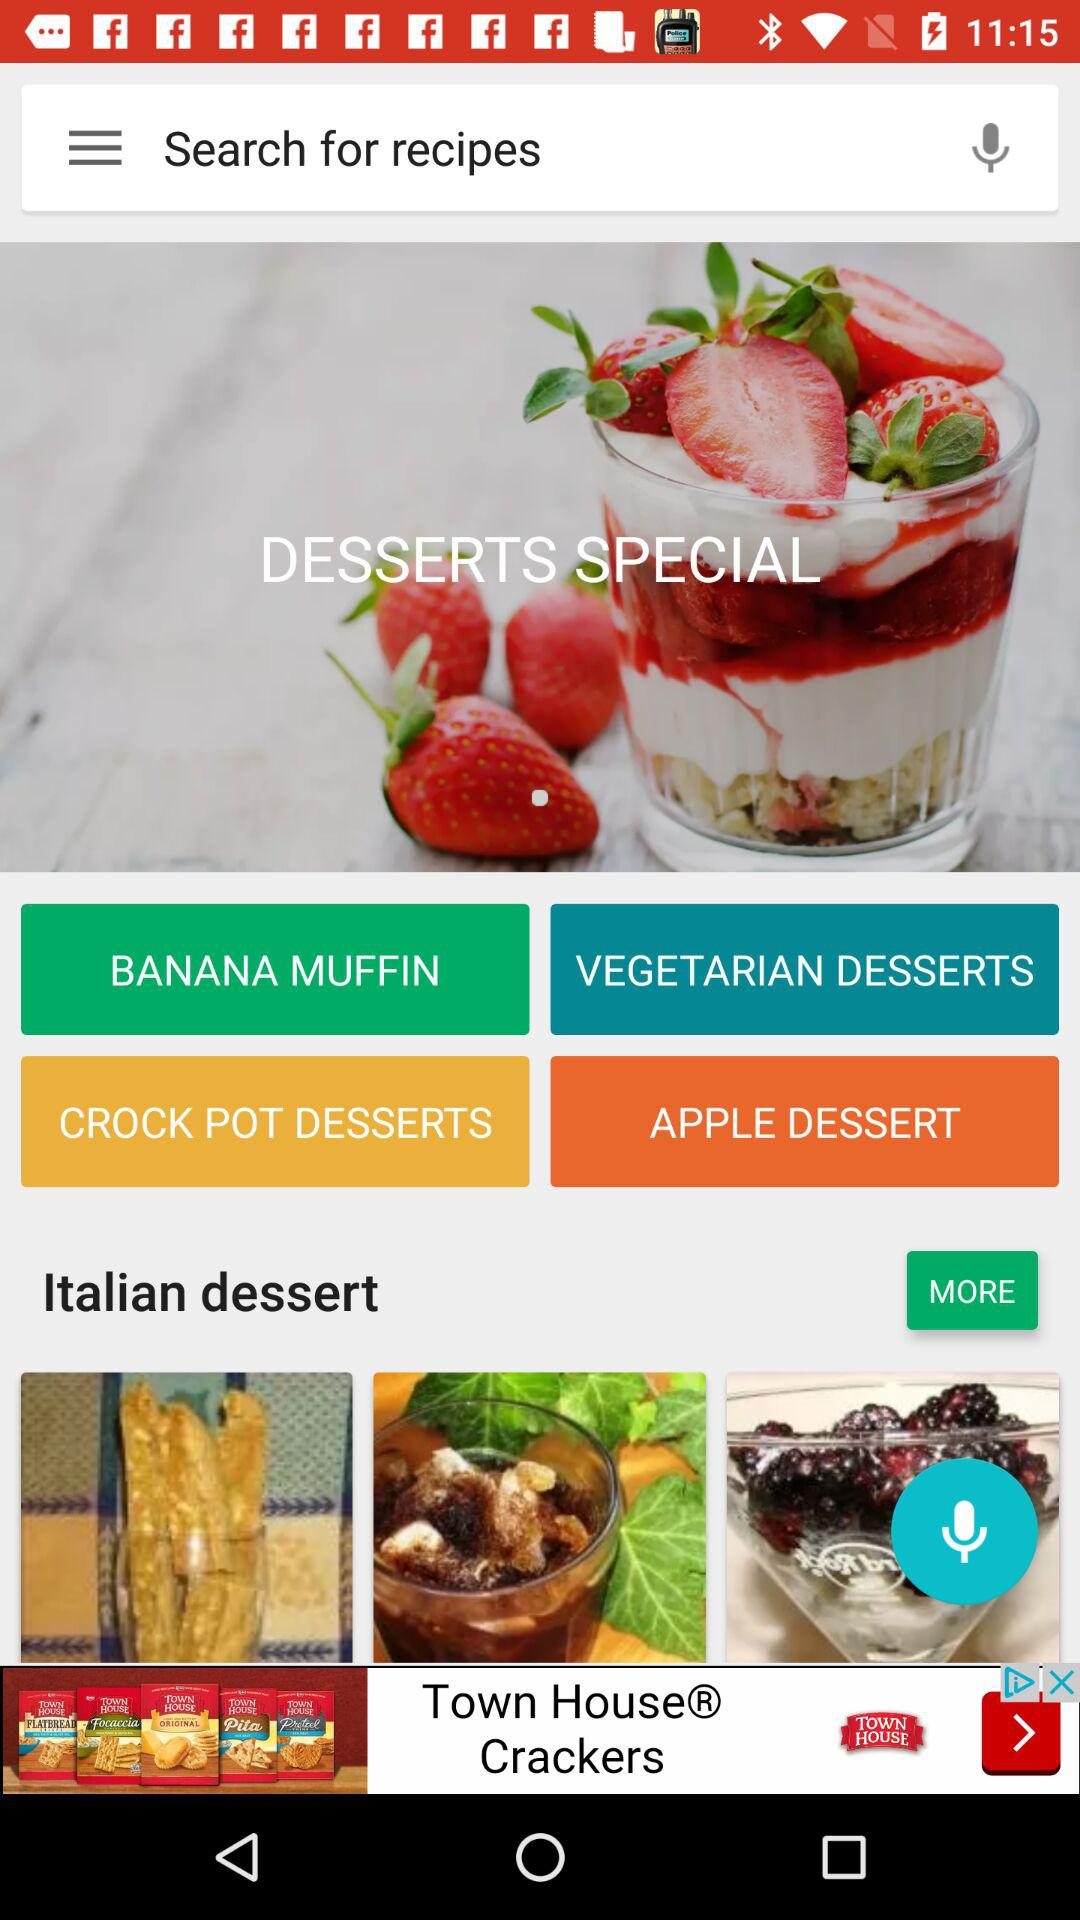What are the different types of desserts in "DESSERTS SPECIAL"? The different types of desserts are "BANANA MUFFIN", "VEGETARIAN DESSERTS", "CROCK POT DESSERTS", "APPLE DESSERT" and "Italian dessert". 